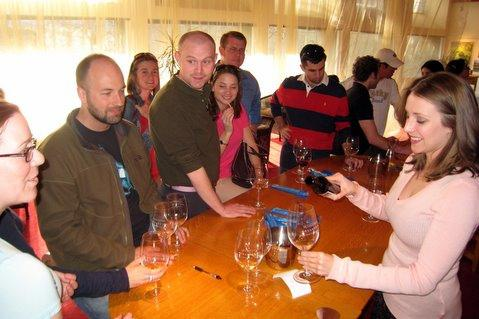What kind of event is this?

Choices:
A) graduation ceremony
B) party
C) church gathering
D) funeral party 